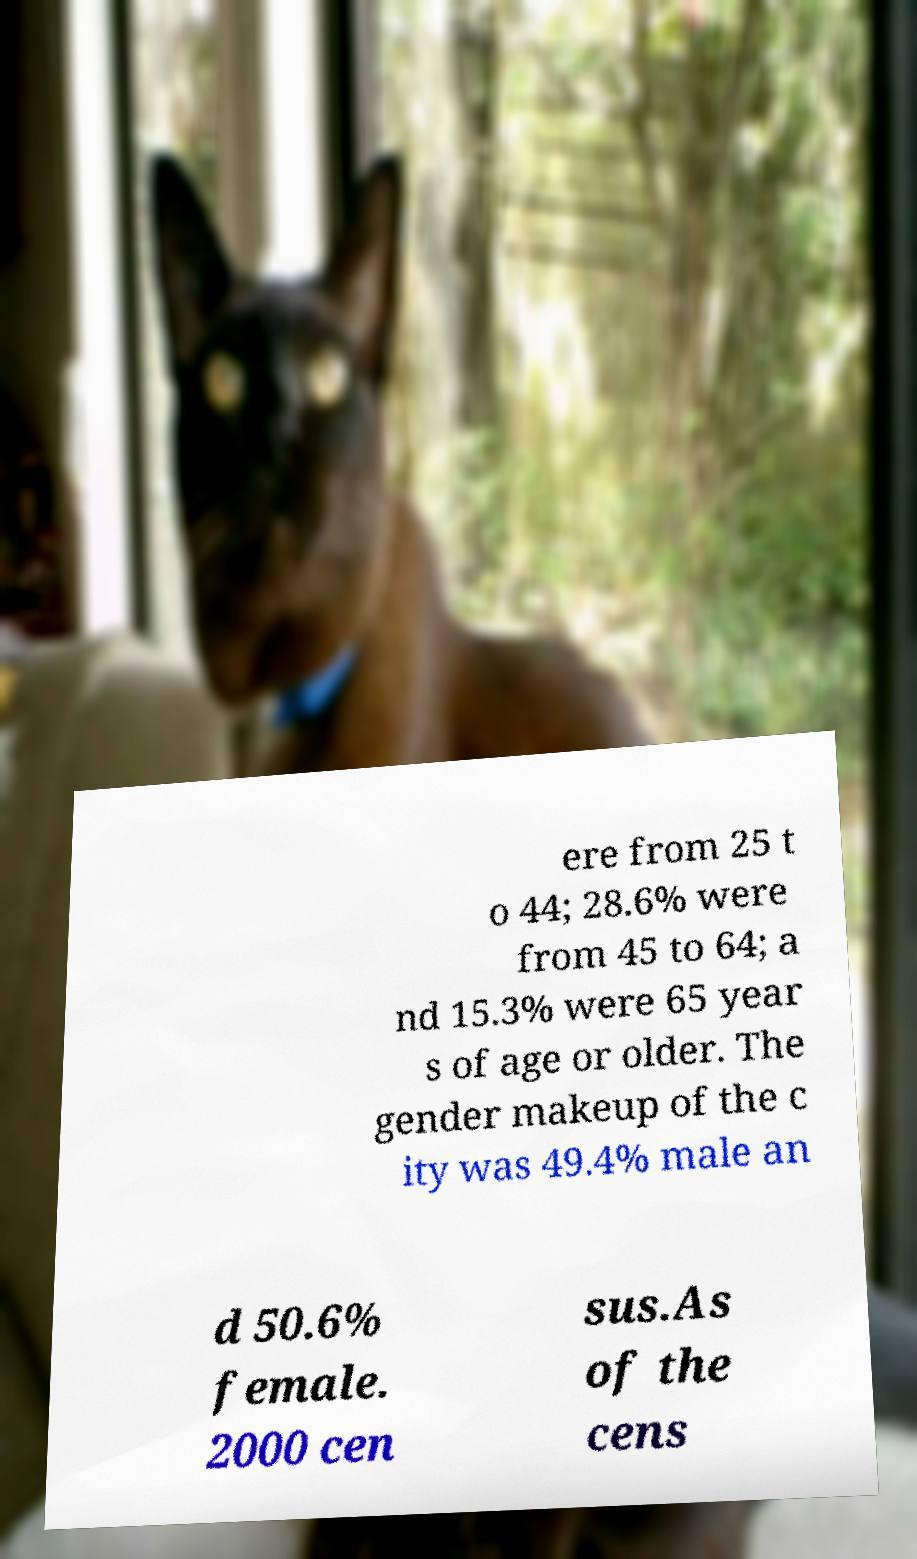Can you read and provide the text displayed in the image?This photo seems to have some interesting text. Can you extract and type it out for me? ere from 25 t o 44; 28.6% were from 45 to 64; a nd 15.3% were 65 year s of age or older. The gender makeup of the c ity was 49.4% male an d 50.6% female. 2000 cen sus.As of the cens 